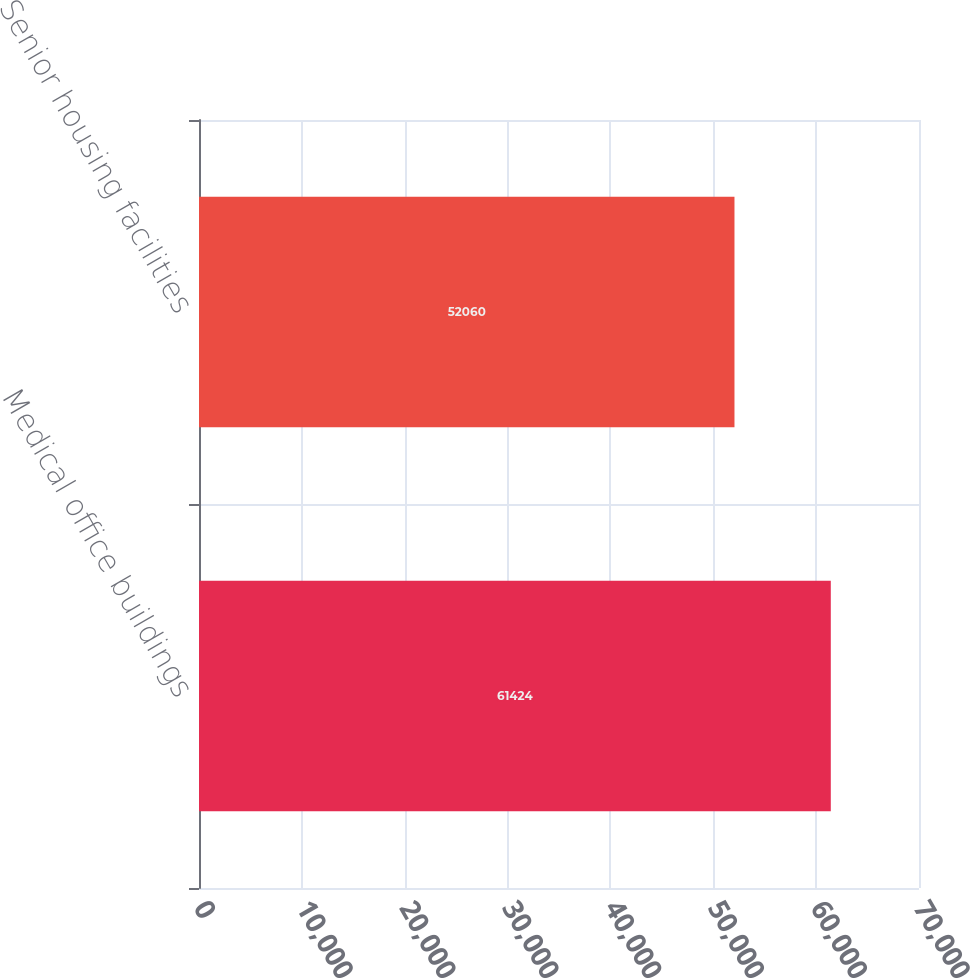Convert chart. <chart><loc_0><loc_0><loc_500><loc_500><bar_chart><fcel>Medical office buildings<fcel>Senior housing facilities<nl><fcel>61424<fcel>52060<nl></chart> 